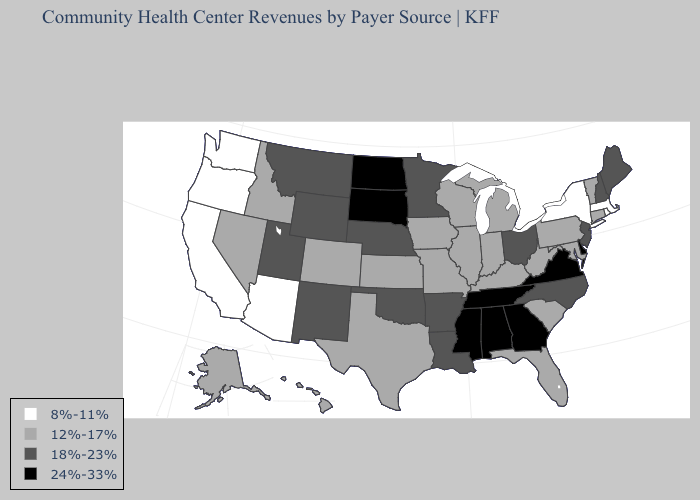Name the states that have a value in the range 12%-17%?
Short answer required. Alaska, Colorado, Connecticut, Florida, Hawaii, Idaho, Illinois, Indiana, Iowa, Kansas, Kentucky, Maryland, Michigan, Missouri, Nevada, Pennsylvania, South Carolina, Texas, Vermont, West Virginia, Wisconsin. Among the states that border Illinois , which have the lowest value?
Short answer required. Indiana, Iowa, Kentucky, Missouri, Wisconsin. Does Missouri have the same value as Colorado?
Answer briefly. Yes. Name the states that have a value in the range 24%-33%?
Answer briefly. Alabama, Delaware, Georgia, Mississippi, North Dakota, South Dakota, Tennessee, Virginia. What is the lowest value in the USA?
Give a very brief answer. 8%-11%. What is the value of Colorado?
Concise answer only. 12%-17%. Name the states that have a value in the range 8%-11%?
Answer briefly. Arizona, California, Massachusetts, New York, Oregon, Rhode Island, Washington. What is the value of Oregon?
Write a very short answer. 8%-11%. Name the states that have a value in the range 24%-33%?
Be succinct. Alabama, Delaware, Georgia, Mississippi, North Dakota, South Dakota, Tennessee, Virginia. Which states have the highest value in the USA?
Quick response, please. Alabama, Delaware, Georgia, Mississippi, North Dakota, South Dakota, Tennessee, Virginia. Which states hav the highest value in the West?
Be succinct. Montana, New Mexico, Utah, Wyoming. How many symbols are there in the legend?
Keep it brief. 4. Name the states that have a value in the range 18%-23%?
Concise answer only. Arkansas, Louisiana, Maine, Minnesota, Montana, Nebraska, New Hampshire, New Jersey, New Mexico, North Carolina, Ohio, Oklahoma, Utah, Wyoming. What is the value of Texas?
Write a very short answer. 12%-17%. Does Arizona have the highest value in the USA?
Write a very short answer. No. 